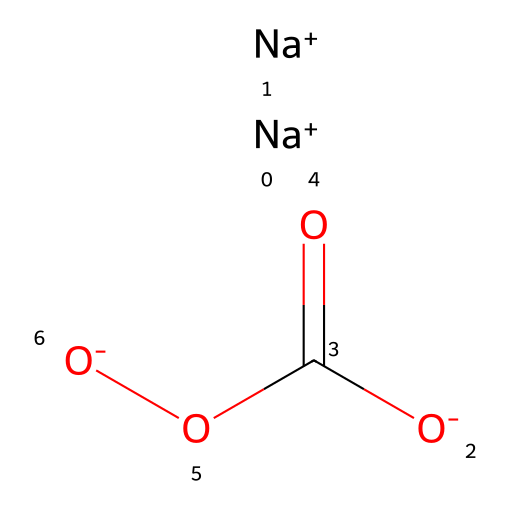What is the molecular formula of sodium percarbonate? Sodium percarbonate consists of two sodium atoms, three oxygen atoms, and one carbon atom. Counting the elements in the SMILES representation confirms this.
Answer: Na2CO3 How many sodium ions are present in the structure? The SMILES representation indicates there are two [Na+] ions present. The notation shows [Na+] twice, which means two sodium atoms are present.
Answer: 2 What type of functional group is present in sodium percarbonate? The SMILES representation shows the presence of a carbonylic group (C=O) alongside the percarbonate structure (O-O). This indicates the presence of peroxo and carbonyl functional groups.
Answer: peroxo complex Is sodium percarbonate an oxidizer? Sodium percarbonate releases oxygen when dissolved in water or decomposed, which is characteristic of oxidizers. This can be deduced from its structure containing peroxo groups, commonly associated with oxidizing properties.
Answer: Yes What is the oxidation state of carbon in sodium percarbonate? The carbon atom is bonded to three oxygens and one of them through a double bond (C=O). The surrounding oxygen atoms contribute to its net oxidation state, which results in carbon having an oxidation state of +4.
Answer: +4 Does sodium percarbonate have acidic properties? Sodium percarbonate is generally neutral due to the presence of sodium ions and the percarbonate group, without the characteristics of strong acids. Upon dissolution, it tends to not release protons.
Answer: No 